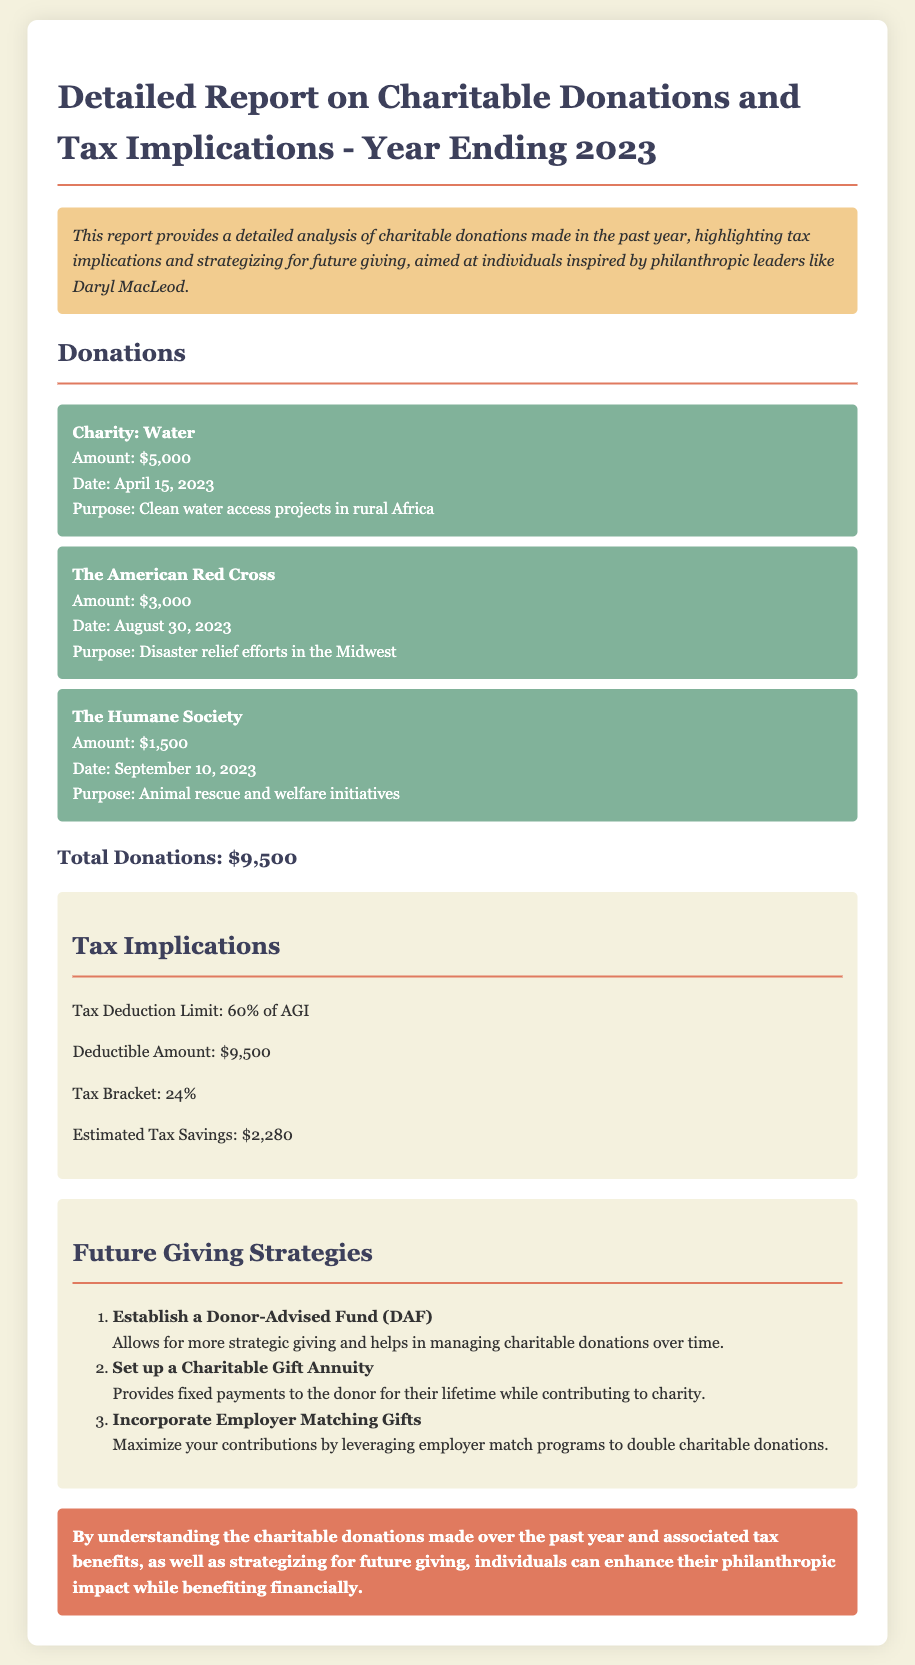What is the total amount donated? The total amount donated is calculated by summing up individual donations listed in the document, which totals $5,000 + $3,000 + $1,500 = $9,500.
Answer: $9,500 What was the donation amount to The Humane Society? The donation amount to The Humane Society is explicitly stated in the document as $1,500.
Answer: $1,500 When was the donation made to The American Red Cross? The date of the donation to The American Red Cross is provided in the document as August 30, 2023.
Answer: August 30, 2023 What is the estimated tax savings? The estimated tax savings derived from the donations is clearly mentioned as $2,280 in the tax implications section.
Answer: $2,280 What percentage of AGI is the tax deduction limit? The document states that the tax deduction limit is 60% of AGI.
Answer: 60% What is one future giving strategy mentioned? The document lists several future giving strategies; one example is to "Establish a Donor-Advised Fund (DAF)."
Answer: Establish a Donor-Advised Fund (DAF) What is the tax bracket indicated in the report? The tax bracket mentioned in the document is 24%.
Answer: 24% What is the purpose of the donation to Charity: Water? The document specifies the purpose of the donation to Charity: Water as "Clean water access projects in rural Africa."
Answer: Clean water access projects in rural Africa How many charities received donations according to the report? The report lists three charities that received donations.
Answer: Three 